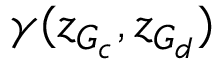<formula> <loc_0><loc_0><loc_500><loc_500>\gamma ( z _ { G _ { c } } , z _ { G _ { d } } )</formula> 